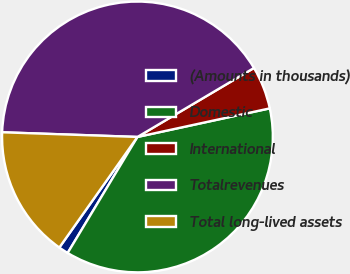<chart> <loc_0><loc_0><loc_500><loc_500><pie_chart><fcel>(Amounts in thousands)<fcel>Domestic<fcel>International<fcel>Totalrevenues<fcel>Total long-lived assets<nl><fcel>1.17%<fcel>37.01%<fcel>5.12%<fcel>40.95%<fcel>15.76%<nl></chart> 